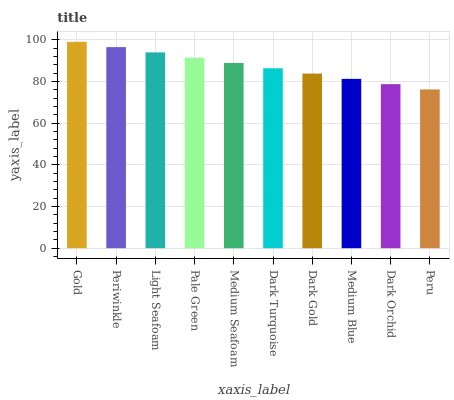Is Peru the minimum?
Answer yes or no. Yes. Is Gold the maximum?
Answer yes or no. Yes. Is Periwinkle the minimum?
Answer yes or no. No. Is Periwinkle the maximum?
Answer yes or no. No. Is Gold greater than Periwinkle?
Answer yes or no. Yes. Is Periwinkle less than Gold?
Answer yes or no. Yes. Is Periwinkle greater than Gold?
Answer yes or no. No. Is Gold less than Periwinkle?
Answer yes or no. No. Is Medium Seafoam the high median?
Answer yes or no. Yes. Is Dark Turquoise the low median?
Answer yes or no. Yes. Is Pale Green the high median?
Answer yes or no. No. Is Peru the low median?
Answer yes or no. No. 